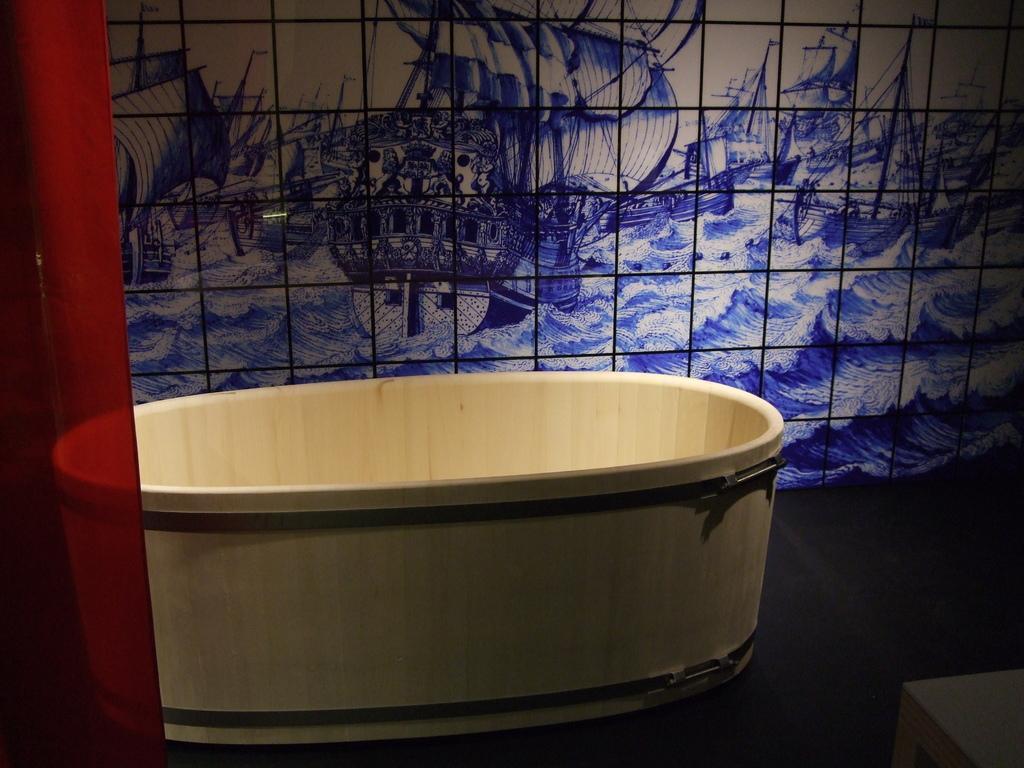How would you summarize this image in a sentence or two? In this image, I can see a tub on the floor. In the bottom right corner of the image, I can see an object. On the left side of the image, I can see a red cloth. In the background, there are tiles. 